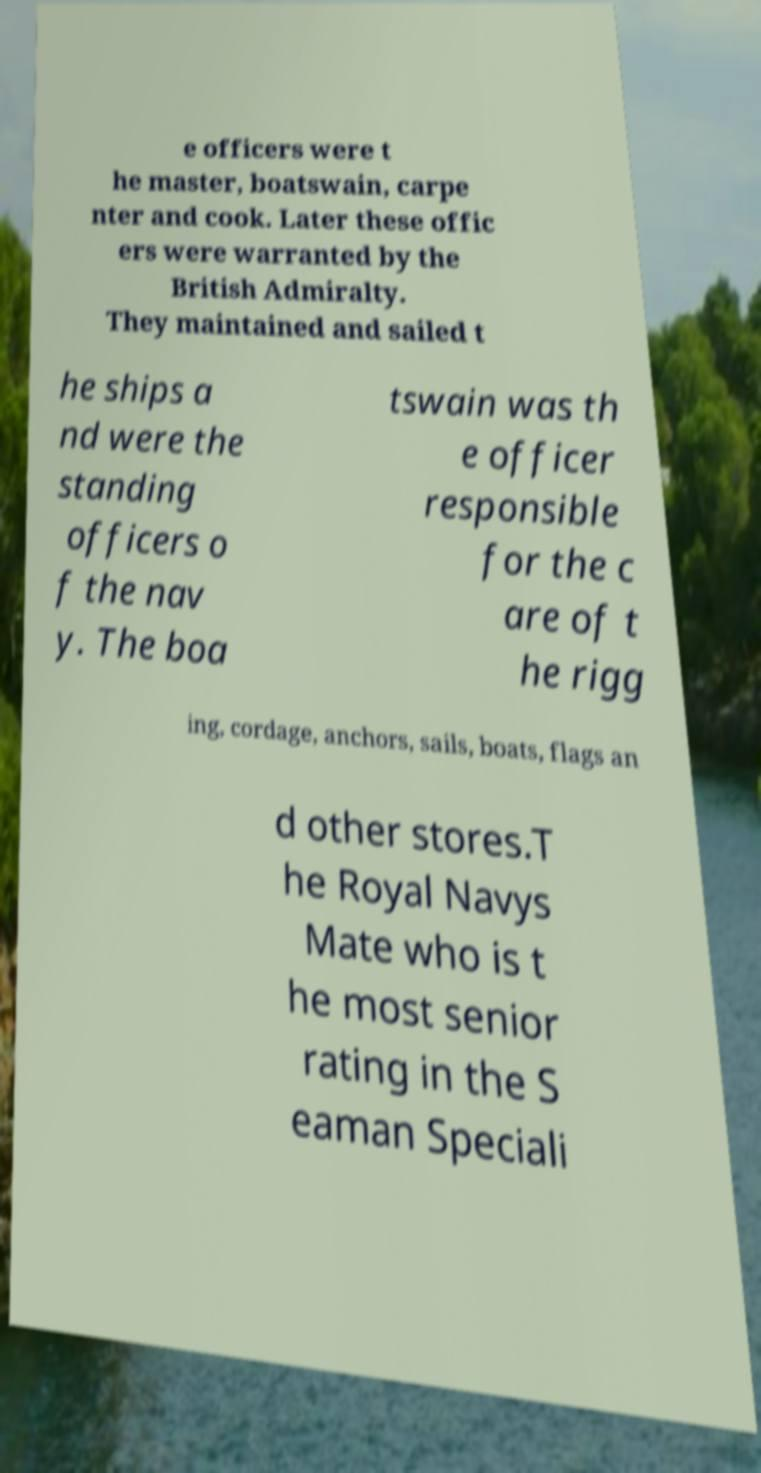What messages or text are displayed in this image? I need them in a readable, typed format. e officers were t he master, boatswain, carpe nter and cook. Later these offic ers were warranted by the British Admiralty. They maintained and sailed t he ships a nd were the standing officers o f the nav y. The boa tswain was th e officer responsible for the c are of t he rigg ing, cordage, anchors, sails, boats, flags an d other stores.T he Royal Navys Mate who is t he most senior rating in the S eaman Speciali 